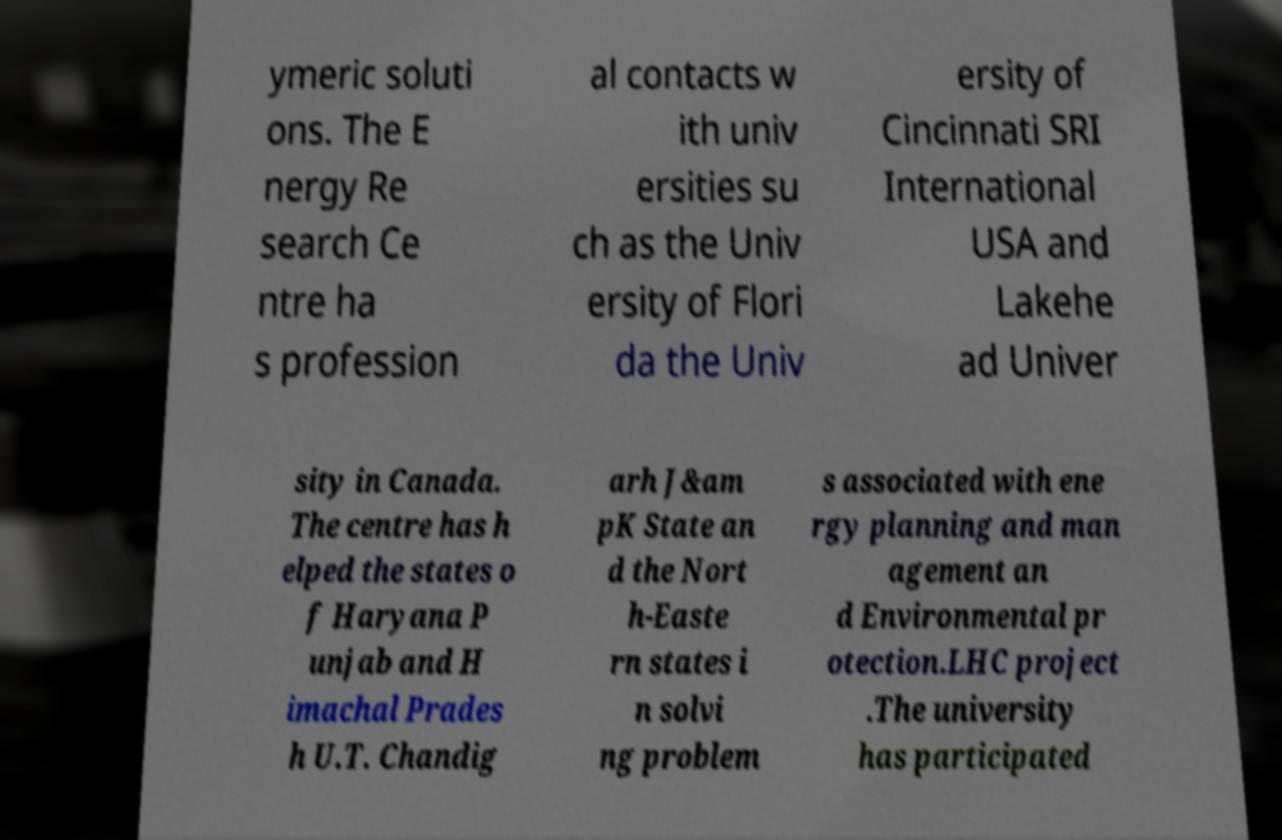Please read and relay the text visible in this image. What does it say? ymeric soluti ons. The E nergy Re search Ce ntre ha s profession al contacts w ith univ ersities su ch as the Univ ersity of Flori da the Univ ersity of Cincinnati SRI International USA and Lakehe ad Univer sity in Canada. The centre has h elped the states o f Haryana P unjab and H imachal Prades h U.T. Chandig arh J&am pK State an d the Nort h-Easte rn states i n solvi ng problem s associated with ene rgy planning and man agement an d Environmental pr otection.LHC project .The university has participated 